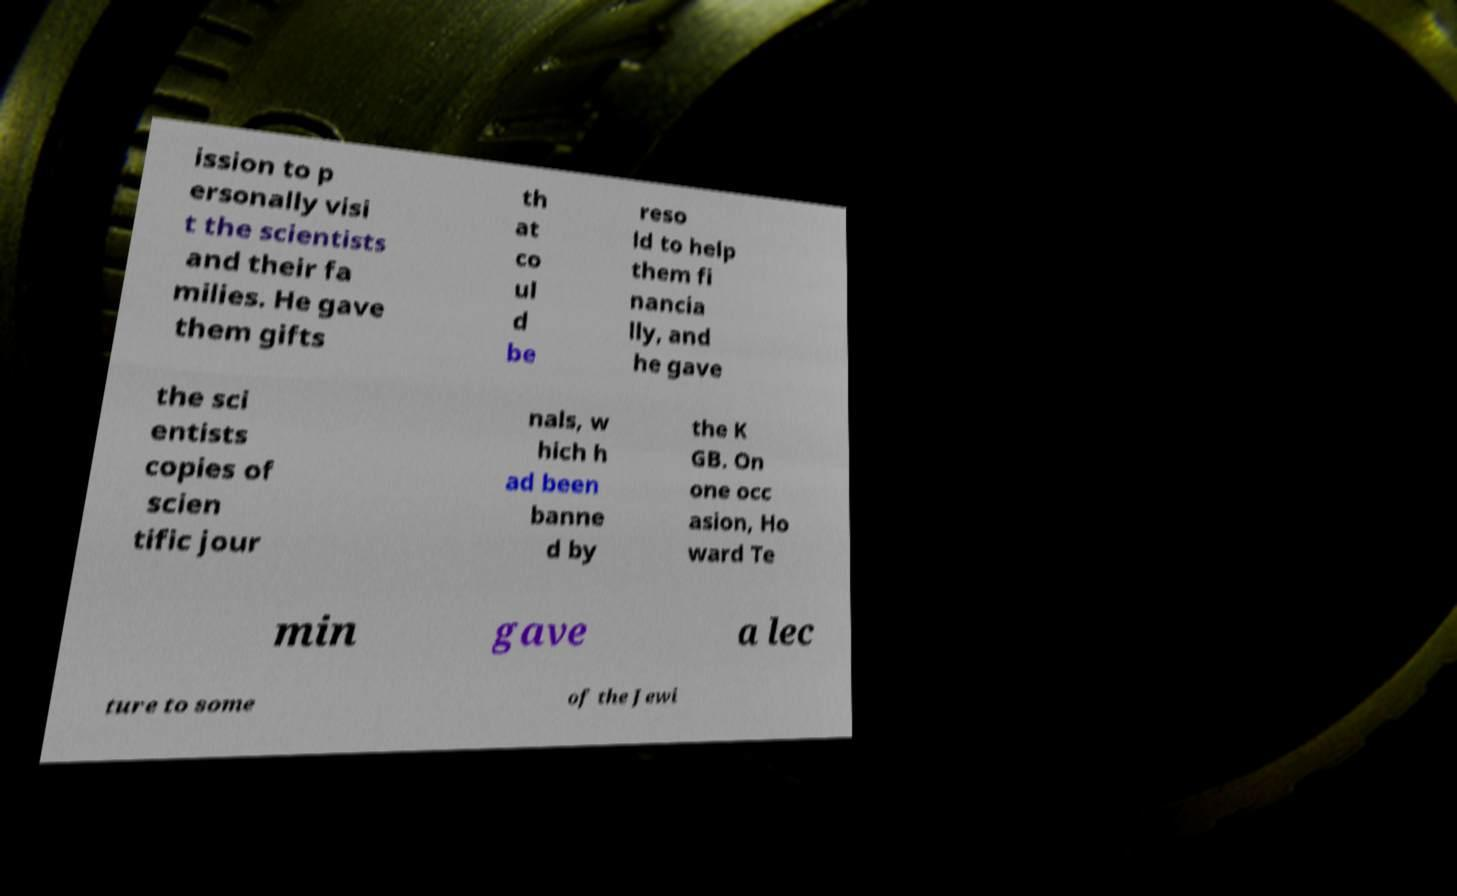Could you extract and type out the text from this image? ission to p ersonally visi t the scientists and their fa milies. He gave them gifts th at co ul d be reso ld to help them fi nancia lly, and he gave the sci entists copies of scien tific jour nals, w hich h ad been banne d by the K GB. On one occ asion, Ho ward Te min gave a lec ture to some of the Jewi 